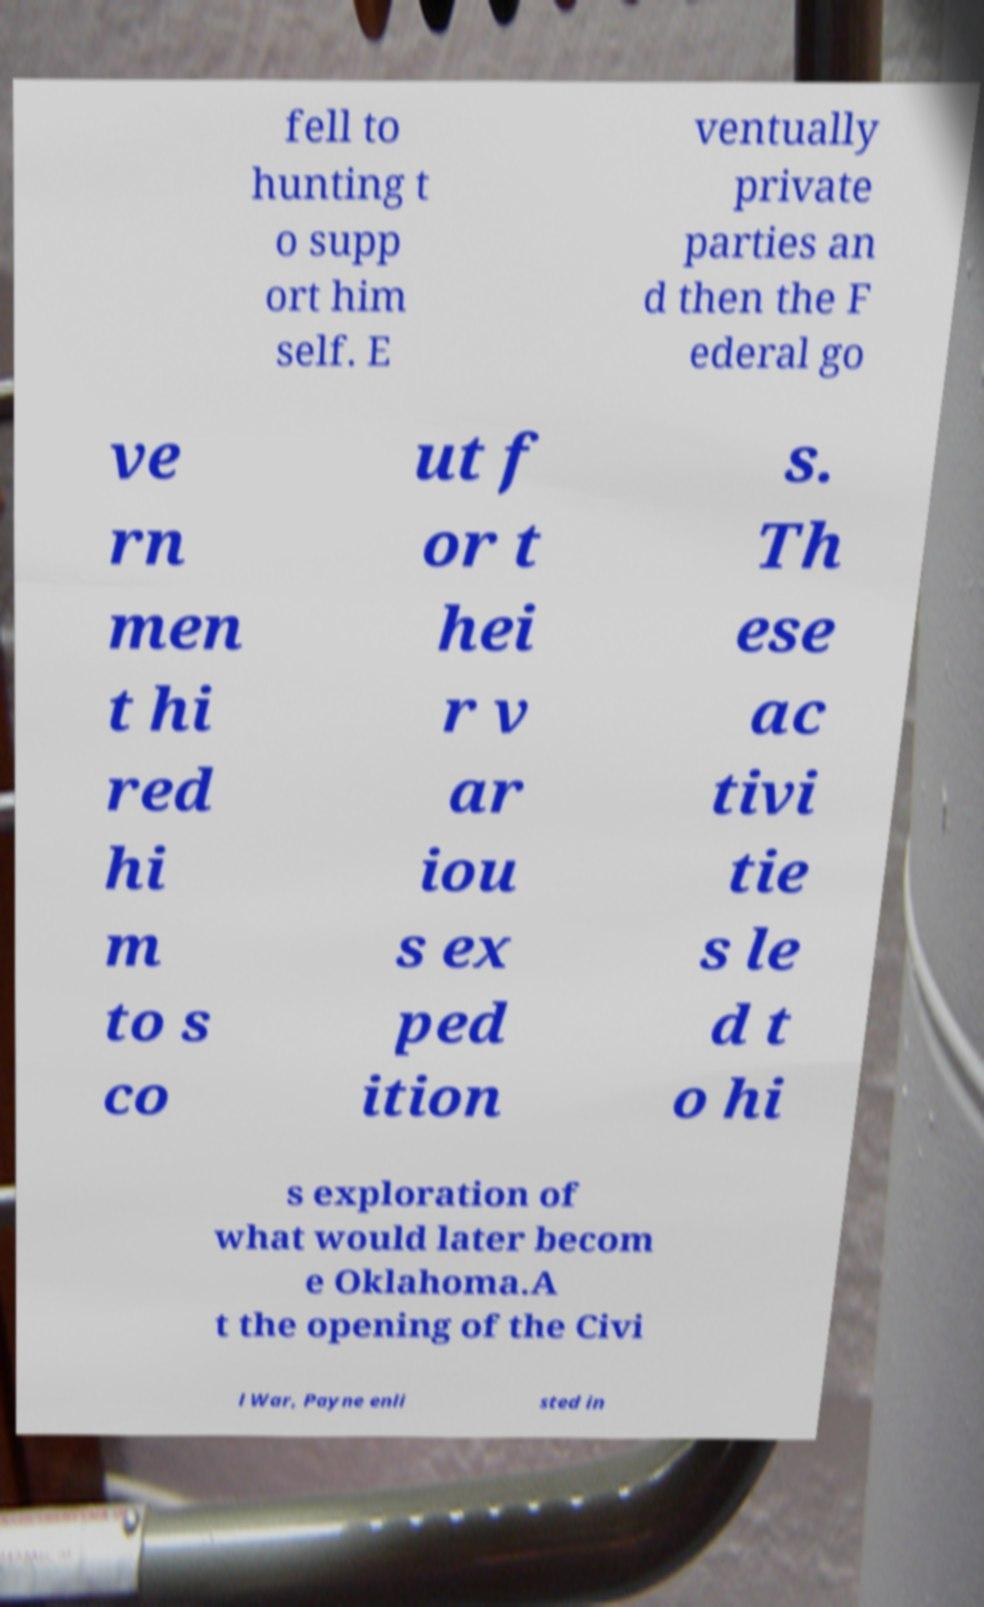Please identify and transcribe the text found in this image. fell to hunting t o supp ort him self. E ventually private parties an d then the F ederal go ve rn men t hi red hi m to s co ut f or t hei r v ar iou s ex ped ition s. Th ese ac tivi tie s le d t o hi s exploration of what would later becom e Oklahoma.A t the opening of the Civi l War, Payne enli sted in 